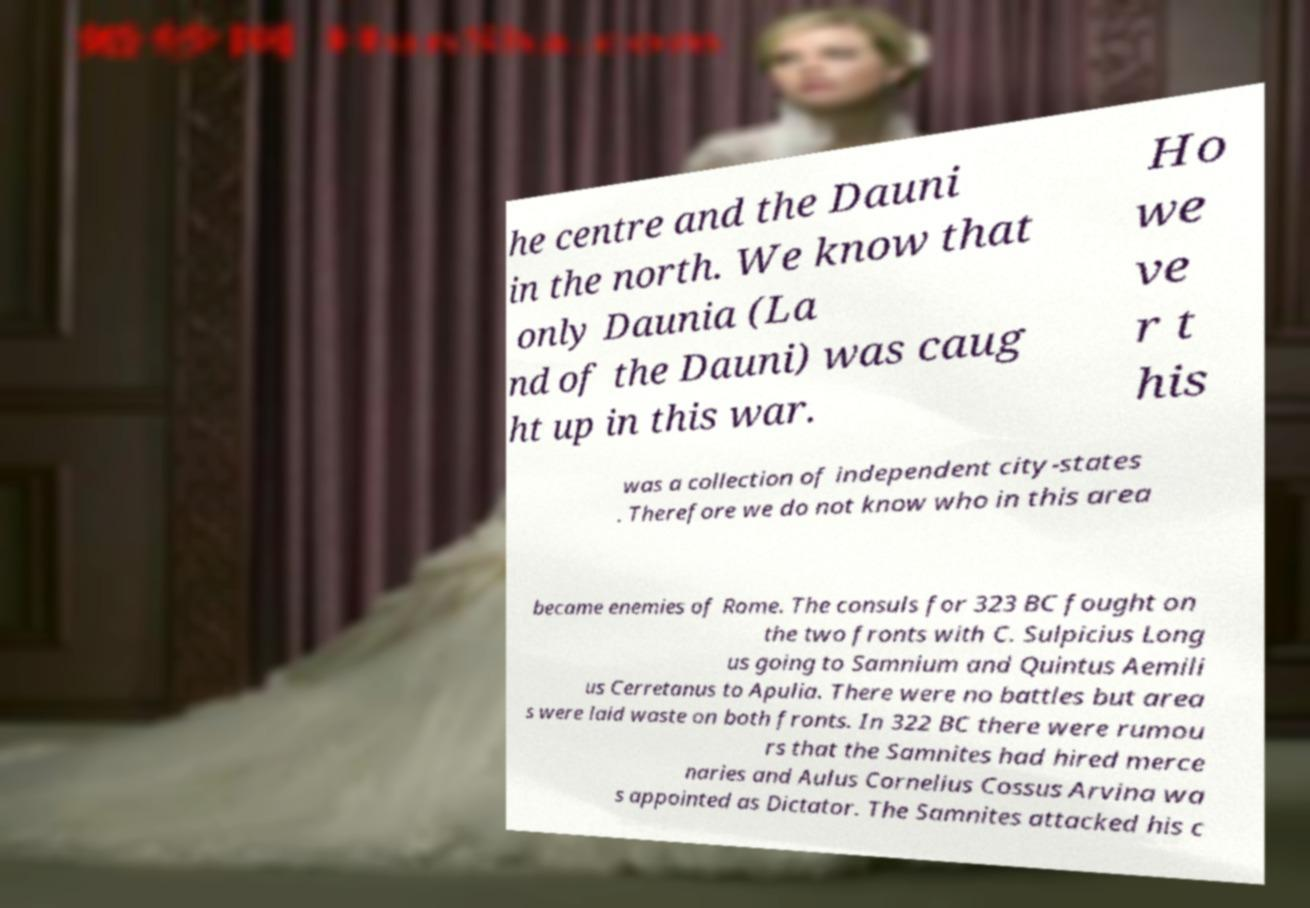Please identify and transcribe the text found in this image. he centre and the Dauni in the north. We know that only Daunia (La nd of the Dauni) was caug ht up in this war. Ho we ve r t his was a collection of independent city-states . Therefore we do not know who in this area became enemies of Rome. The consuls for 323 BC fought on the two fronts with C. Sulpicius Long us going to Samnium and Quintus Aemili us Cerretanus to Apulia. There were no battles but area s were laid waste on both fronts. In 322 BC there were rumou rs that the Samnites had hired merce naries and Aulus Cornelius Cossus Arvina wa s appointed as Dictator. The Samnites attacked his c 